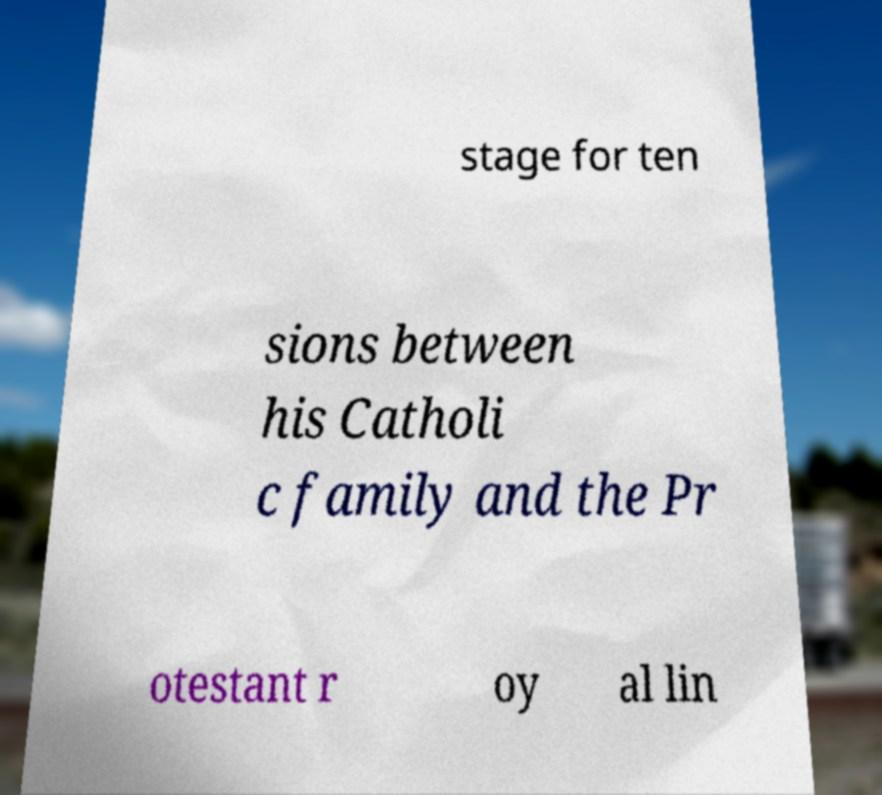I need the written content from this picture converted into text. Can you do that? stage for ten sions between his Catholi c family and the Pr otestant r oy al lin 